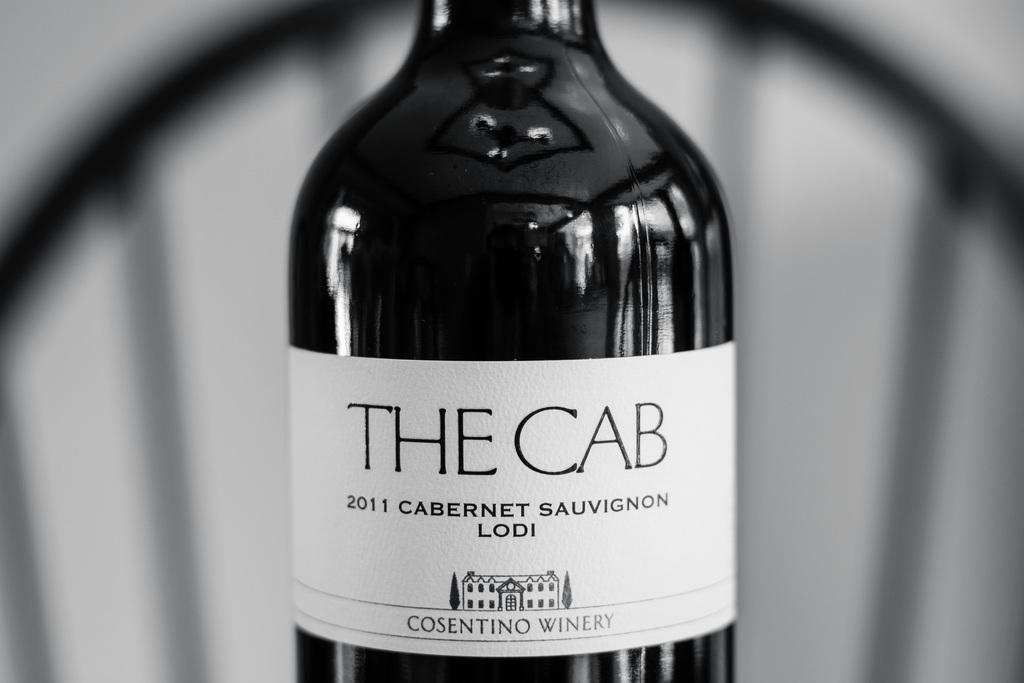<image>
Give a short and clear explanation of the subsequent image. A bottle of THE CAB 2011 CABERNET SAUVIGNON LODI wine is shown partially. 